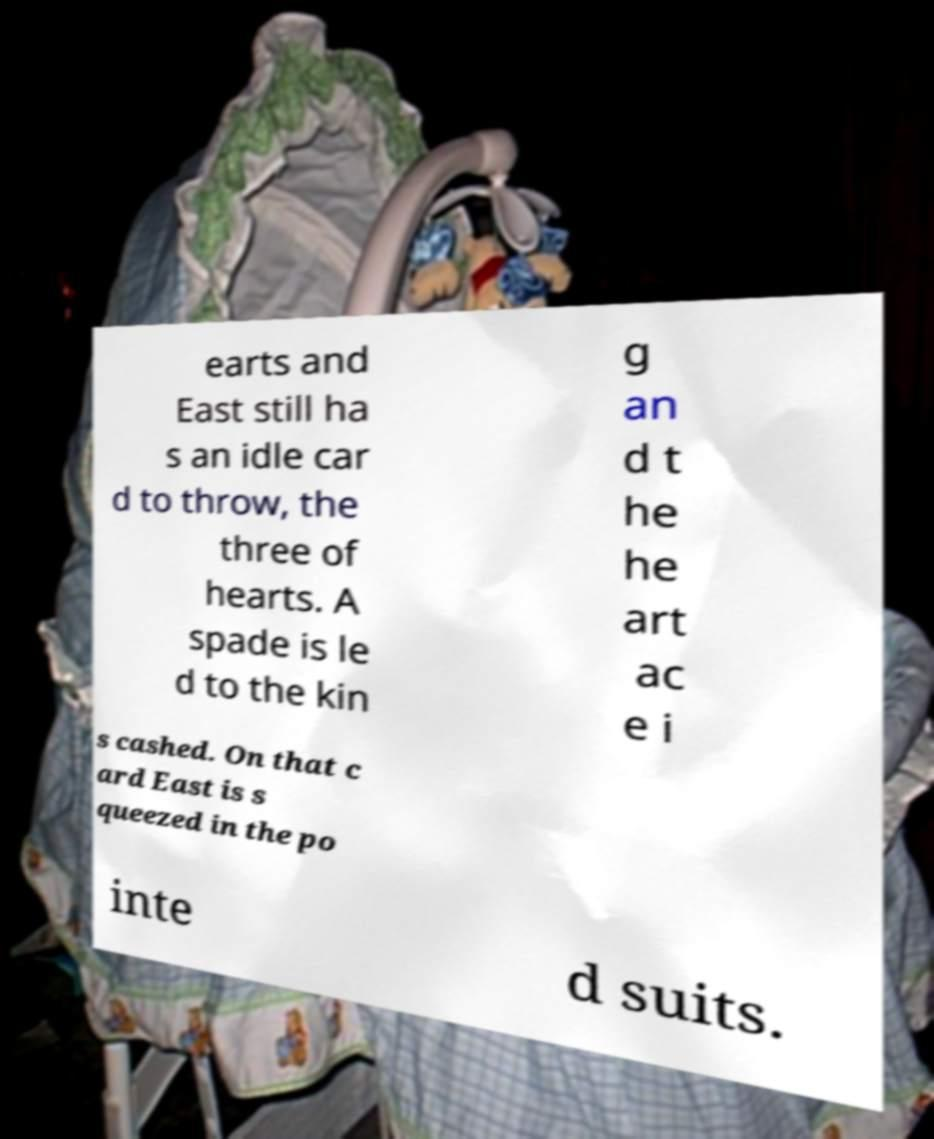What messages or text are displayed in this image? I need them in a readable, typed format. earts and East still ha s an idle car d to throw, the three of hearts. A spade is le d to the kin g an d t he he art ac e i s cashed. On that c ard East is s queezed in the po inte d suits. 